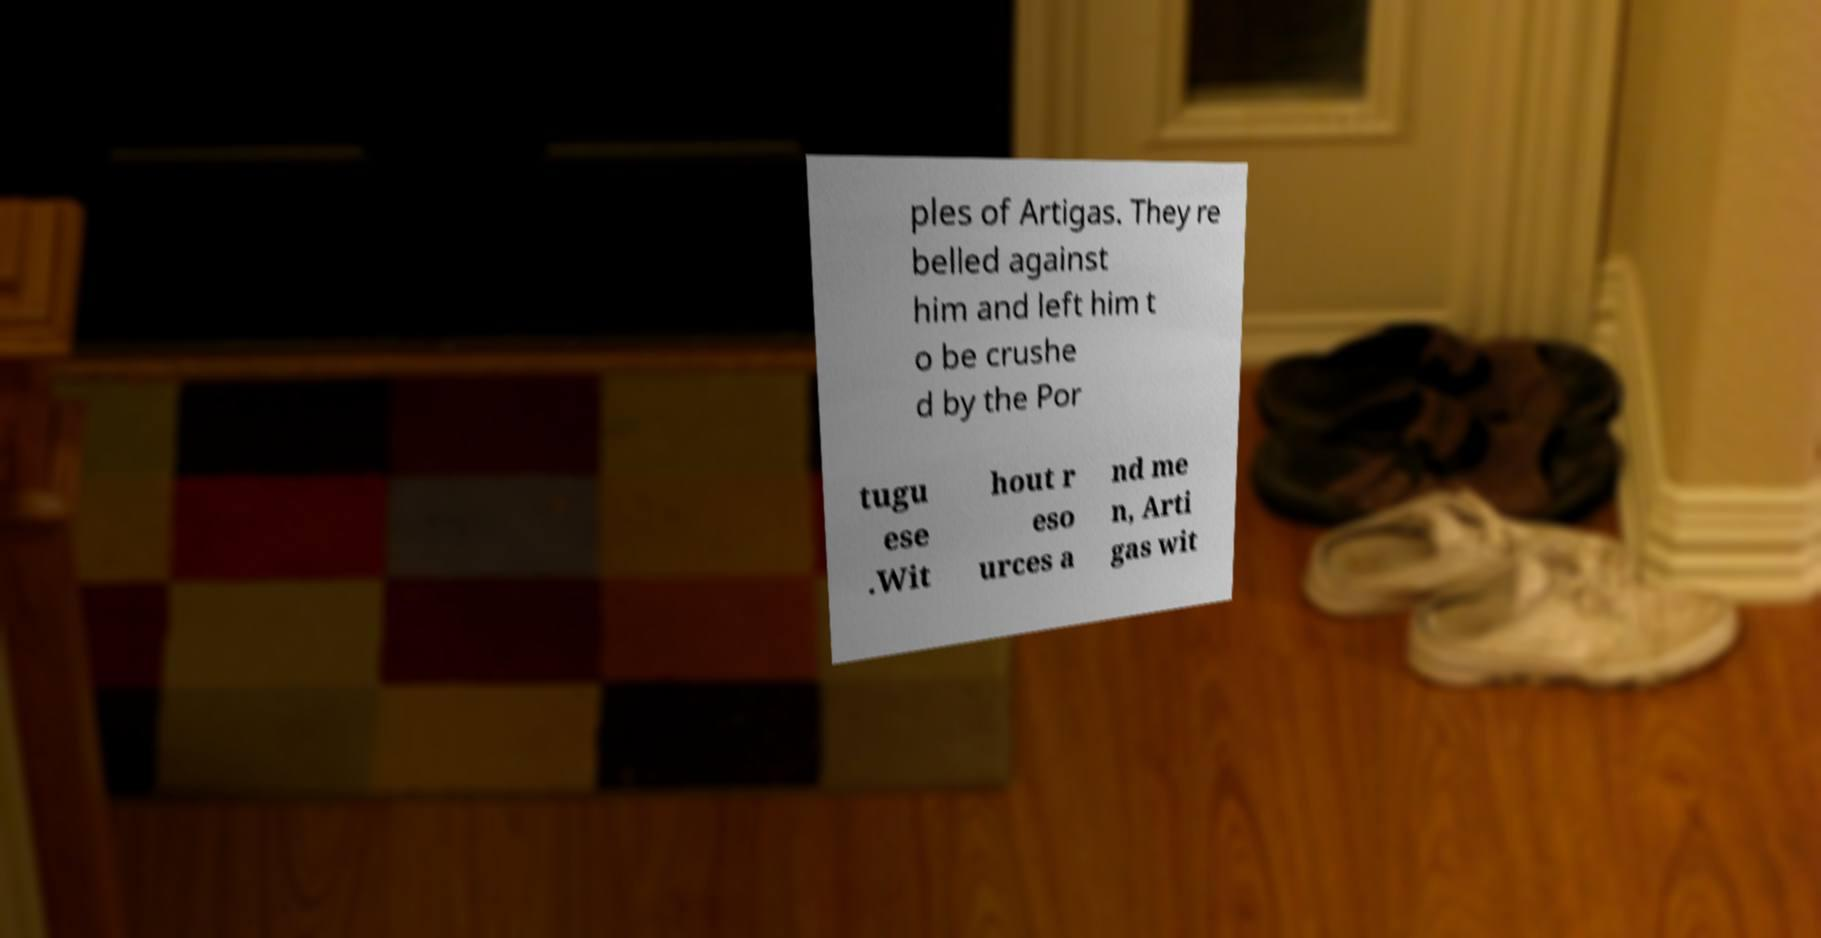For documentation purposes, I need the text within this image transcribed. Could you provide that? ples of Artigas. They re belled against him and left him t o be crushe d by the Por tugu ese .Wit hout r eso urces a nd me n, Arti gas wit 